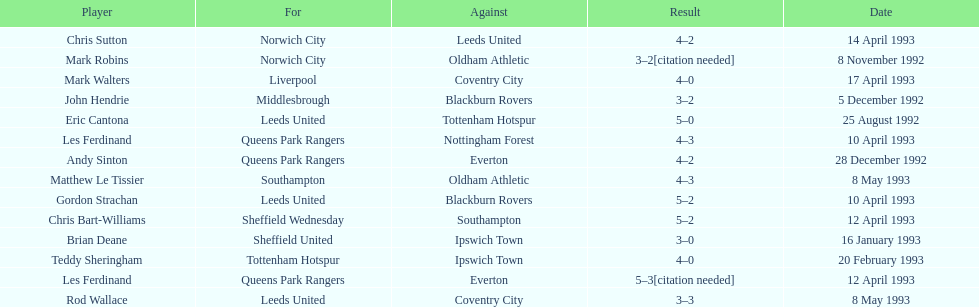Name the players for tottenham hotspur. Teddy Sheringham. 